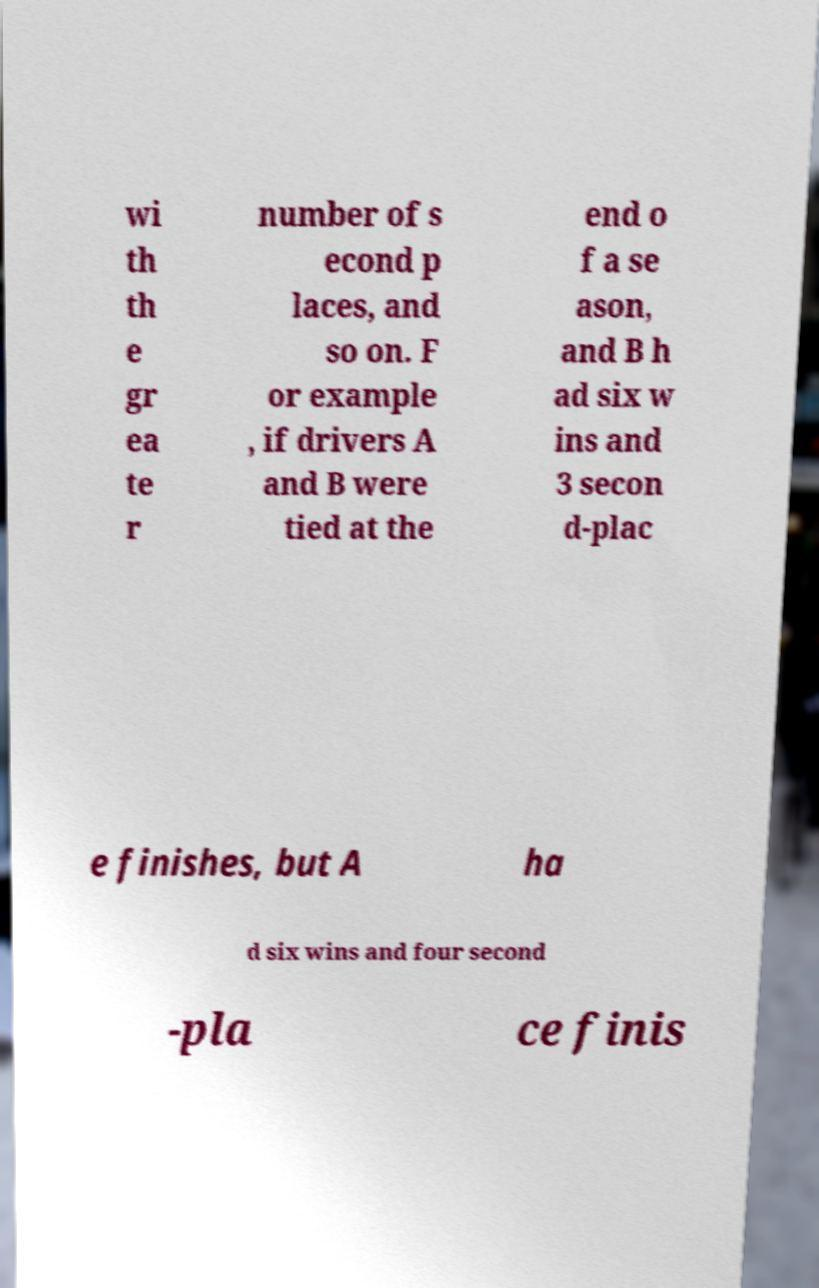Can you read and provide the text displayed in the image?This photo seems to have some interesting text. Can you extract and type it out for me? wi th th e gr ea te r number of s econd p laces, and so on. F or example , if drivers A and B were tied at the end o f a se ason, and B h ad six w ins and 3 secon d-plac e finishes, but A ha d six wins and four second -pla ce finis 